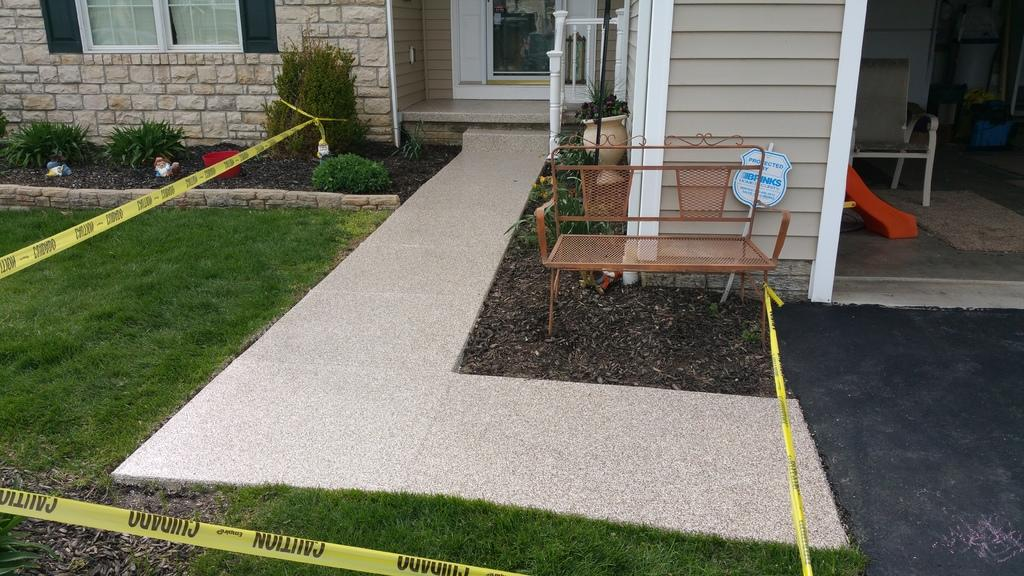What type of warning or instruction is depicted in the image? There is a caution tag in the image. What type of natural environment is visible in the image? There is grass in the image. What type of seating is present in the image? There is a bench in the image. What type of indoor plants are visible in the image? There are house plants in the image. What type of architectural feature is present in the image? There is a wall in the image. What type of opening in the wall is visible in the image? There is a window in the image. What type of entrance or exit is visible in the image? There is a door in the image. Where is the island located in the image? There is no island present in the image. What type of books are visible on the bench in the image? There are no books visible on the bench in the image. 